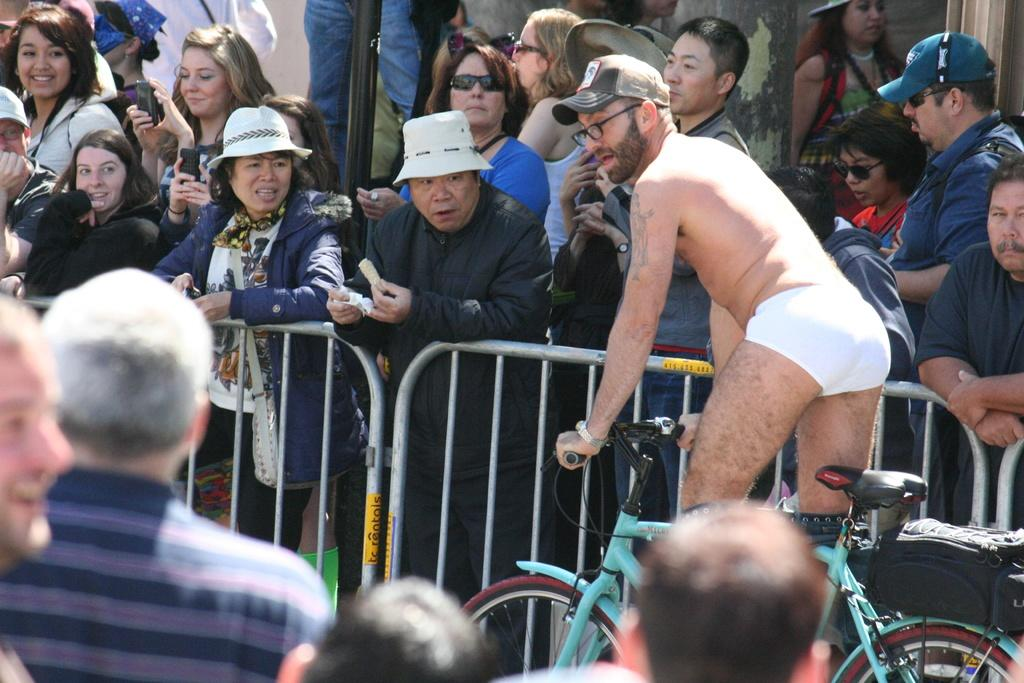What are the people in the image doing? There are persons standing on the road, and one person is riding a bicycle. What objects can be seen in the image besides the people? There are poles visible in the image, and there are grills present as well. What type of magic is being performed with the vase in the image? There is no vase present in the image, and therefore no magic can be observed. 